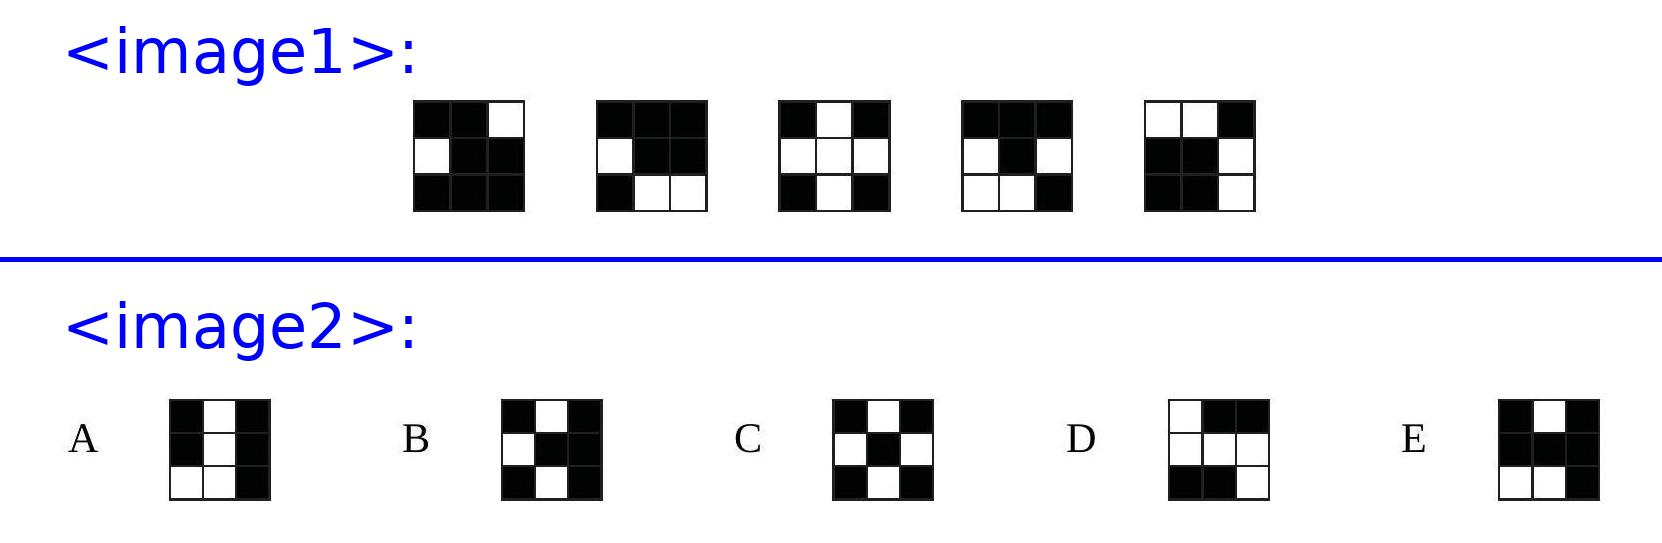A $3 \times 3 \times 3$ cube is built from 15 black cubes and 12 white cubes. Five faces of the larger cube are shown. Which of the following is the sixth face of the larger cube? Choices: ['A', 'B', 'C', 'D', 'E'] The correct answer is 'A'. After analyzing the visible sides of the cube in the first image, it is evident that the configuration of black and white cubes in option 'A' from the second image complements the existing visible faces correctly, maintaining the count of 15 black and 12 white cubes while ensuring each face has a unique pattern. 